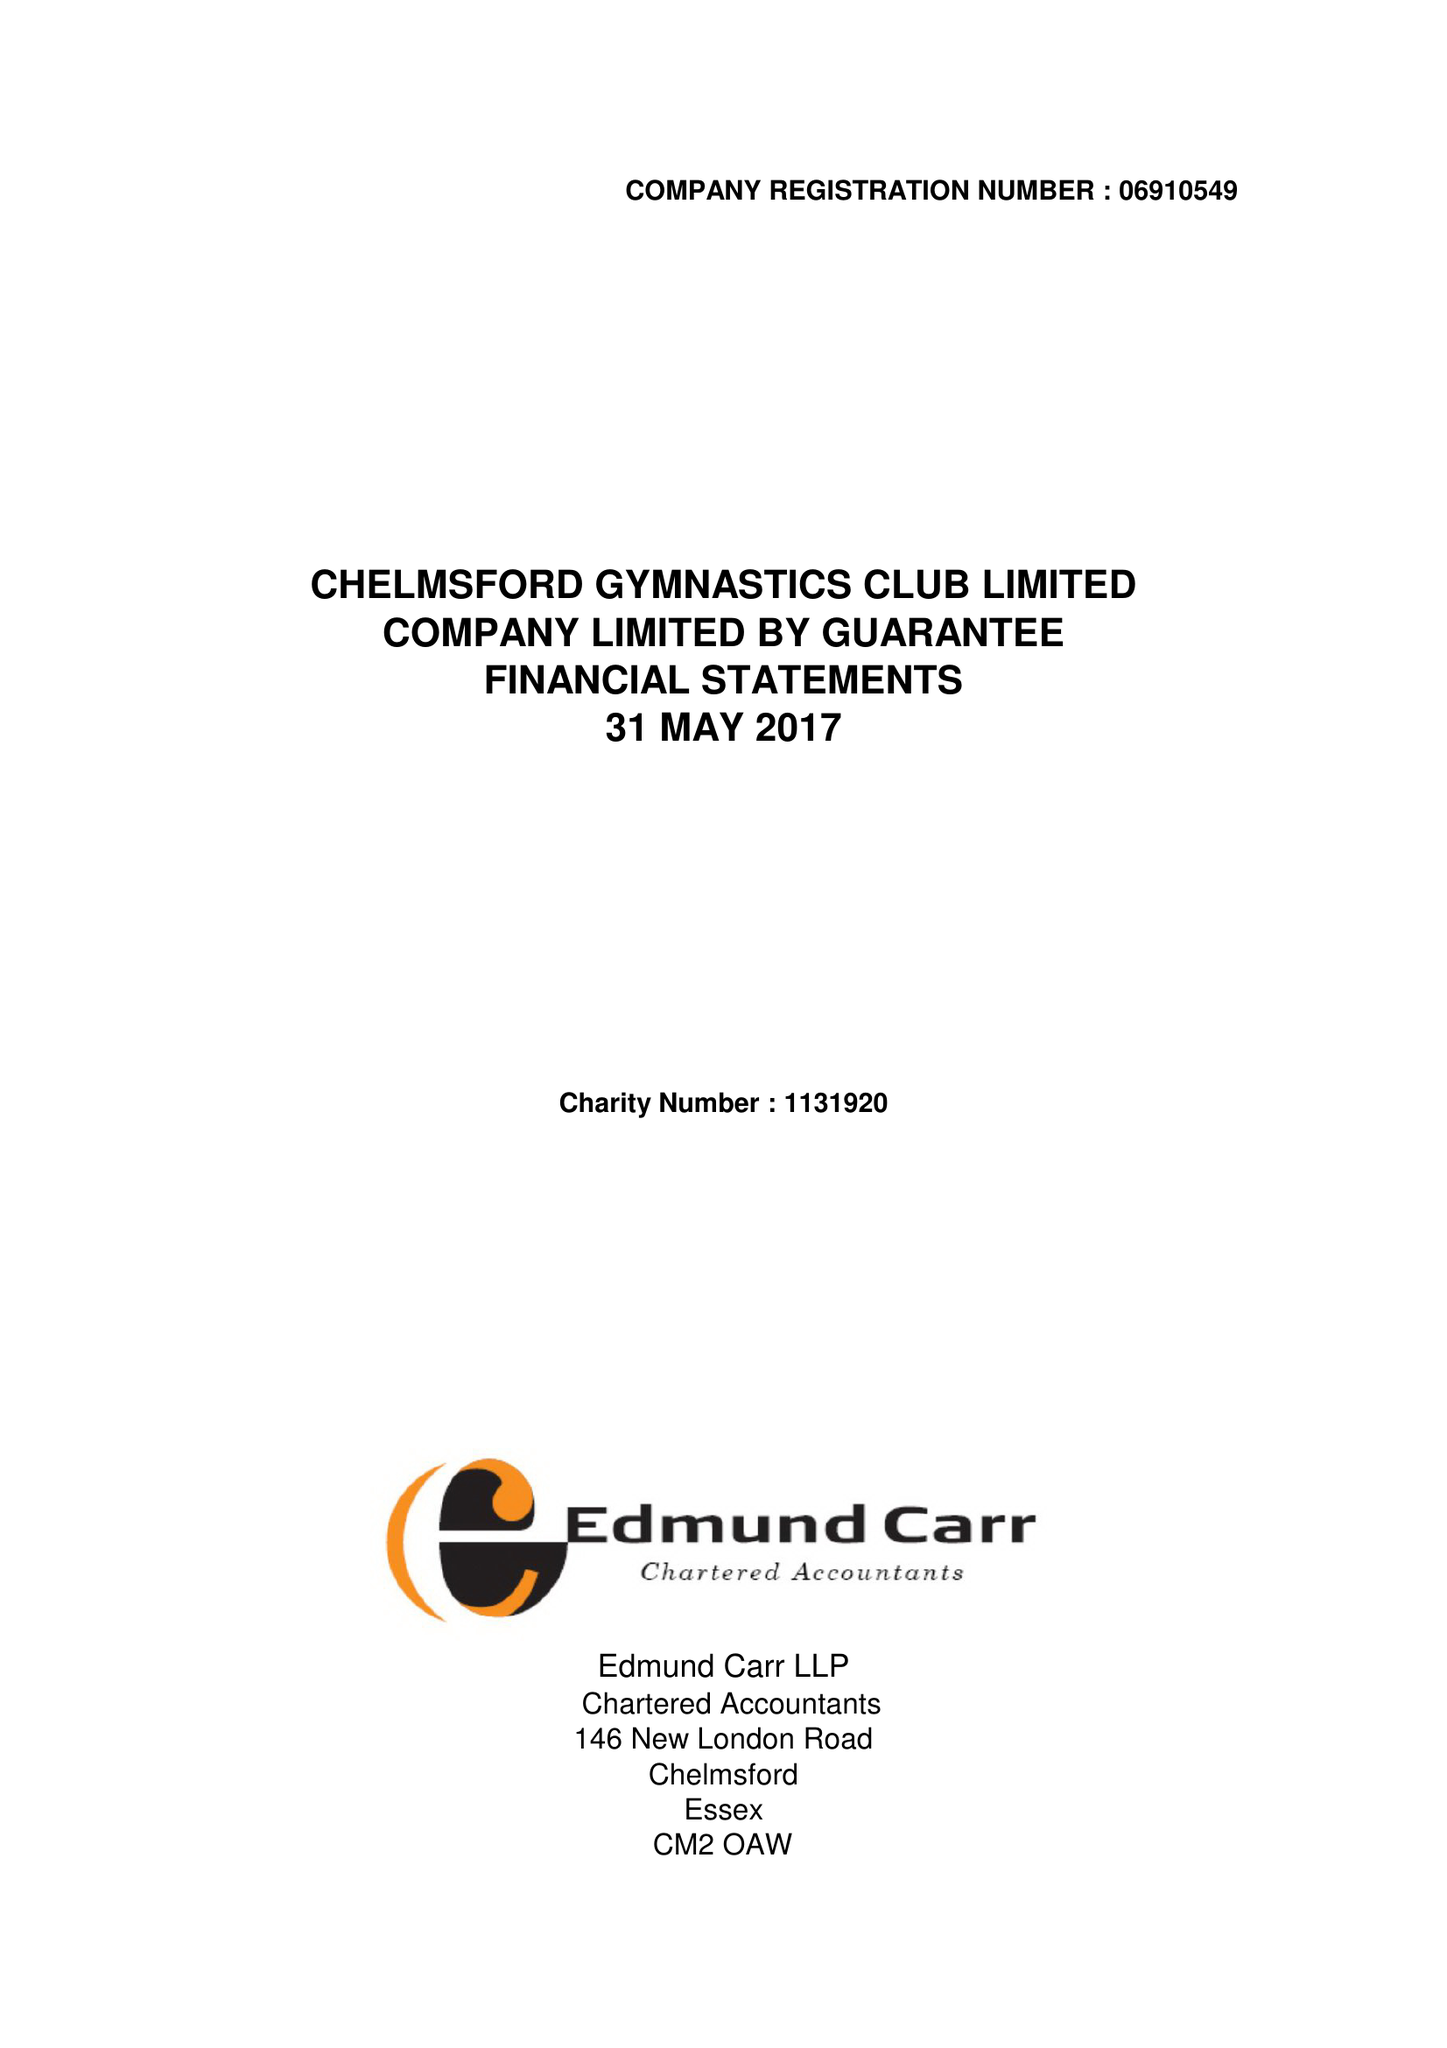What is the value for the address__post_town?
Answer the question using a single word or phrase. CHELMSFORD 